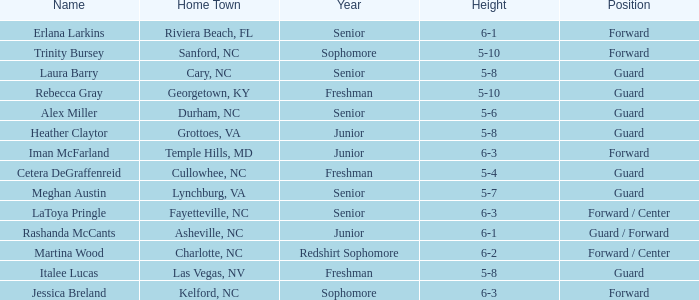How tall is the freshman guard Cetera Degraffenreid? 5-4. 